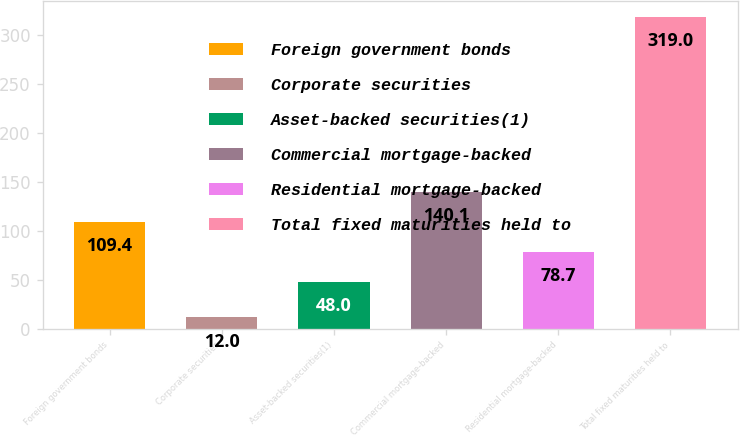Convert chart to OTSL. <chart><loc_0><loc_0><loc_500><loc_500><bar_chart><fcel>Foreign government bonds<fcel>Corporate securities<fcel>Asset-backed securities(1)<fcel>Commercial mortgage-backed<fcel>Residential mortgage-backed<fcel>Total fixed maturities held to<nl><fcel>109.4<fcel>12<fcel>48<fcel>140.1<fcel>78.7<fcel>319<nl></chart> 